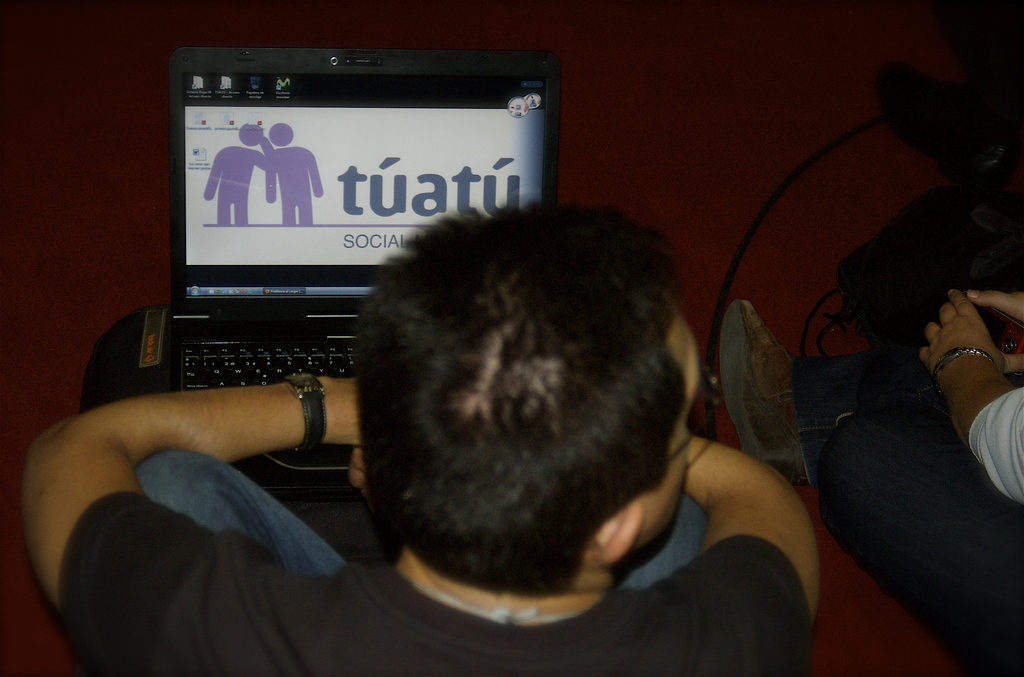What does the social aspect mentioned on the Tuatu page suggest about the website? The social aspect on the Tuatu page suggests that the website focuses on fostering social connections or community building, likely offering features that enhance interpersonal interactions online. 